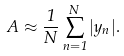Convert formula to latex. <formula><loc_0><loc_0><loc_500><loc_500>A \approx \frac { 1 } { N } \sum _ { n = 1 } ^ { N } | y _ { n } | .</formula> 